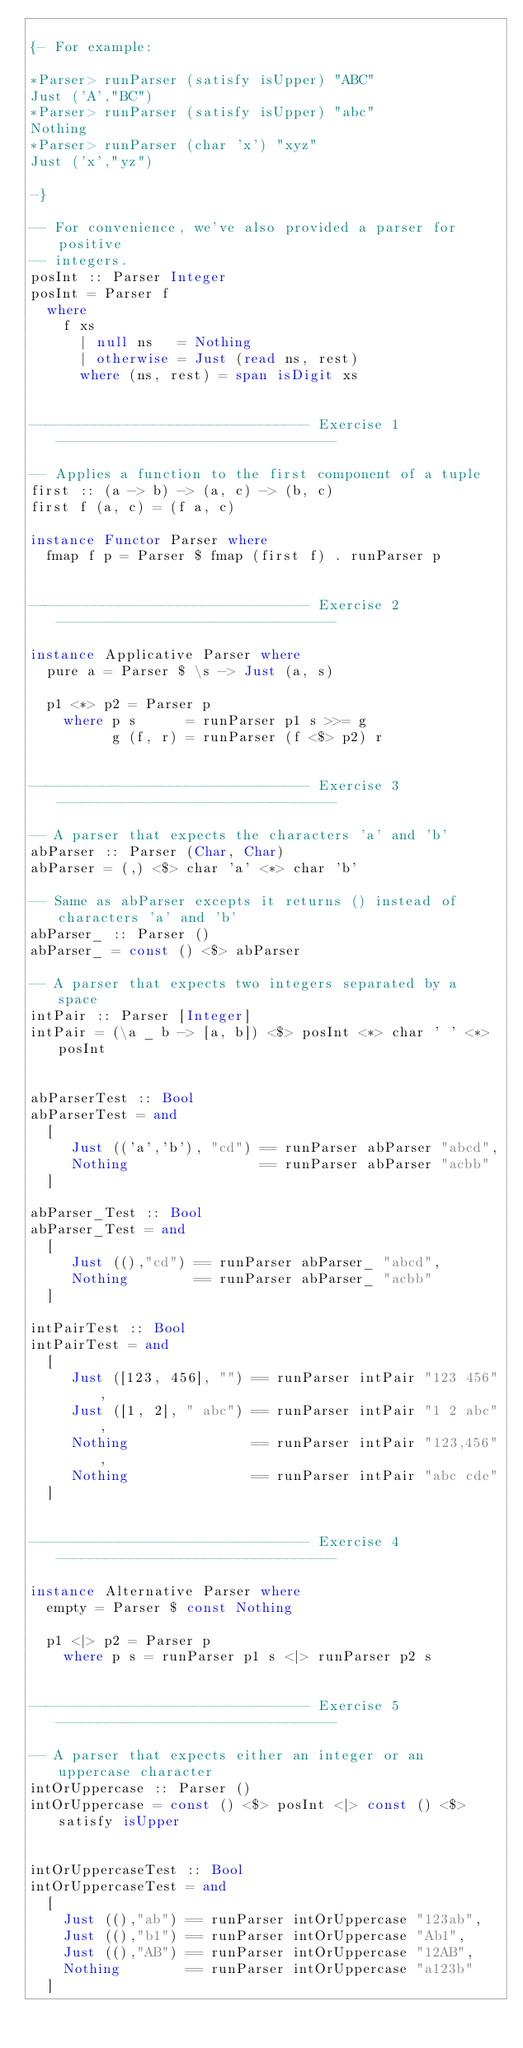<code> <loc_0><loc_0><loc_500><loc_500><_Haskell_>
{- For example:

*Parser> runParser (satisfy isUpper) "ABC"
Just ('A',"BC")
*Parser> runParser (satisfy isUpper) "abc"
Nothing
*Parser> runParser (char 'x') "xyz"
Just ('x',"yz")

-}

-- For convenience, we've also provided a parser for positive
-- integers.
posInt :: Parser Integer
posInt = Parser f
  where
    f xs
      | null ns   = Nothing
      | otherwise = Just (read ns, rest)
      where (ns, rest) = span isDigit xs


---------------------------------- Exercise 1 ----------------------------------

-- Applies a function to the first component of a tuple
first :: (a -> b) -> (a, c) -> (b, c)
first f (a, c) = (f a, c)

instance Functor Parser where
  fmap f p = Parser $ fmap (first f) . runParser p


---------------------------------- Exercise 2 ----------------------------------

instance Applicative Parser where
  pure a = Parser $ \s -> Just (a, s)

  p1 <*> p2 = Parser p
    where p s      = runParser p1 s >>= g
          g (f, r) = runParser (f <$> p2) r


---------------------------------- Exercise 3 ----------------------------------

-- A parser that expects the characters 'a' and 'b'
abParser :: Parser (Char, Char)
abParser = (,) <$> char 'a' <*> char 'b'

-- Same as abParser excepts it returns () instead of characters 'a' and 'b'
abParser_ :: Parser ()
abParser_ = const () <$> abParser

-- A parser that expects two integers separated by a space
intPair :: Parser [Integer]
intPair = (\a _ b -> [a, b]) <$> posInt <*> char ' ' <*> posInt


abParserTest :: Bool
abParserTest = and
  [
     Just (('a','b'), "cd") == runParser abParser "abcd",
     Nothing                == runParser abParser "acbb"
  ]

abParser_Test :: Bool
abParser_Test = and
  [
     Just ((),"cd") == runParser abParser_ "abcd",
     Nothing        == runParser abParser_ "acbb"
  ]

intPairTest :: Bool
intPairTest = and
  [
     Just ([123, 456], "") == runParser intPair "123 456",
     Just ([1, 2], " abc") == runParser intPair "1 2 abc",
     Nothing               == runParser intPair "123,456",
     Nothing               == runParser intPair "abc cde"
  ]


---------------------------------- Exercise 4 ----------------------------------

instance Alternative Parser where
  empty = Parser $ const Nothing

  p1 <|> p2 = Parser p
    where p s = runParser p1 s <|> runParser p2 s


---------------------------------- Exercise 5 ----------------------------------

-- A parser that expects either an integer or an uppercase character
intOrUppercase :: Parser ()
intOrUppercase = const () <$> posInt <|> const () <$> satisfy isUpper


intOrUppercaseTest :: Bool
intOrUppercaseTest = and
  [
    Just ((),"ab") == runParser intOrUppercase "123ab",
    Just ((),"b1") == runParser intOrUppercase "Ab1",
    Just ((),"AB") == runParser intOrUppercase "12AB",
    Nothing        == runParser intOrUppercase "a123b"
  ]
</code> 